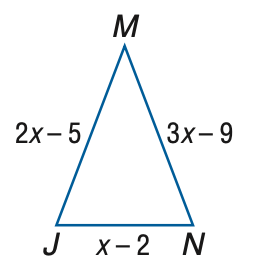Question: Find M N if \triangle J M N is an isosceles triangle with J M \cong M N.
Choices:
A. 2
B. 3
C. 4
D. 5
Answer with the letter. Answer: B Question: Find x if \triangle J M N is an isosceles triangle with J M \cong M N.
Choices:
A. 2
B. 3
C. 4
D. 4
Answer with the letter. Answer: C Question: Find J N if \triangle J M N is an isosceles triangle with J M \cong M N.
Choices:
A. 2
B. 3
C. 4
D. 5
Answer with the letter. Answer: A Question: Find J M if \triangle J M N is an isosceles triangle with J M \cong M N.
Choices:
A. 2
B. 3
C. 4
D. 5
Answer with the letter. Answer: B 